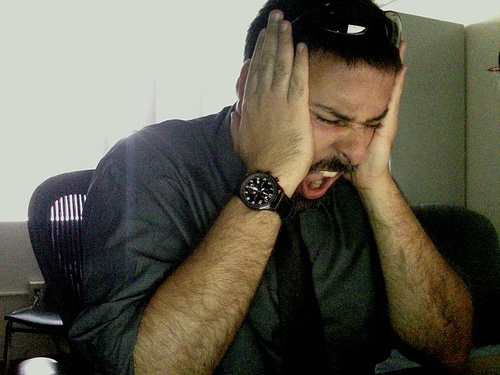Describe the objects in this image and their specific colors. I can see people in lightgray, black, gray, olive, and tan tones, chair in lightgray, black, and gray tones, couch in lightgray, black, and darkgreen tones, tie in lightgray, black, maroon, and gray tones, and dining table in black, maroon, darkgreen, and lightgray tones in this image. 